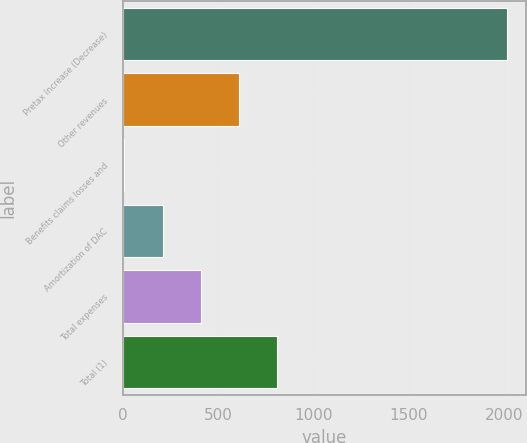Convert chart. <chart><loc_0><loc_0><loc_500><loc_500><bar_chart><fcel>Pretax Increase (Decrease)<fcel>Other revenues<fcel>Benefits claims losses and<fcel>Amortization of DAC<fcel>Total expenses<fcel>Total (1)<nl><fcel>2014<fcel>608.4<fcel>6<fcel>206.8<fcel>407.6<fcel>809.2<nl></chart> 